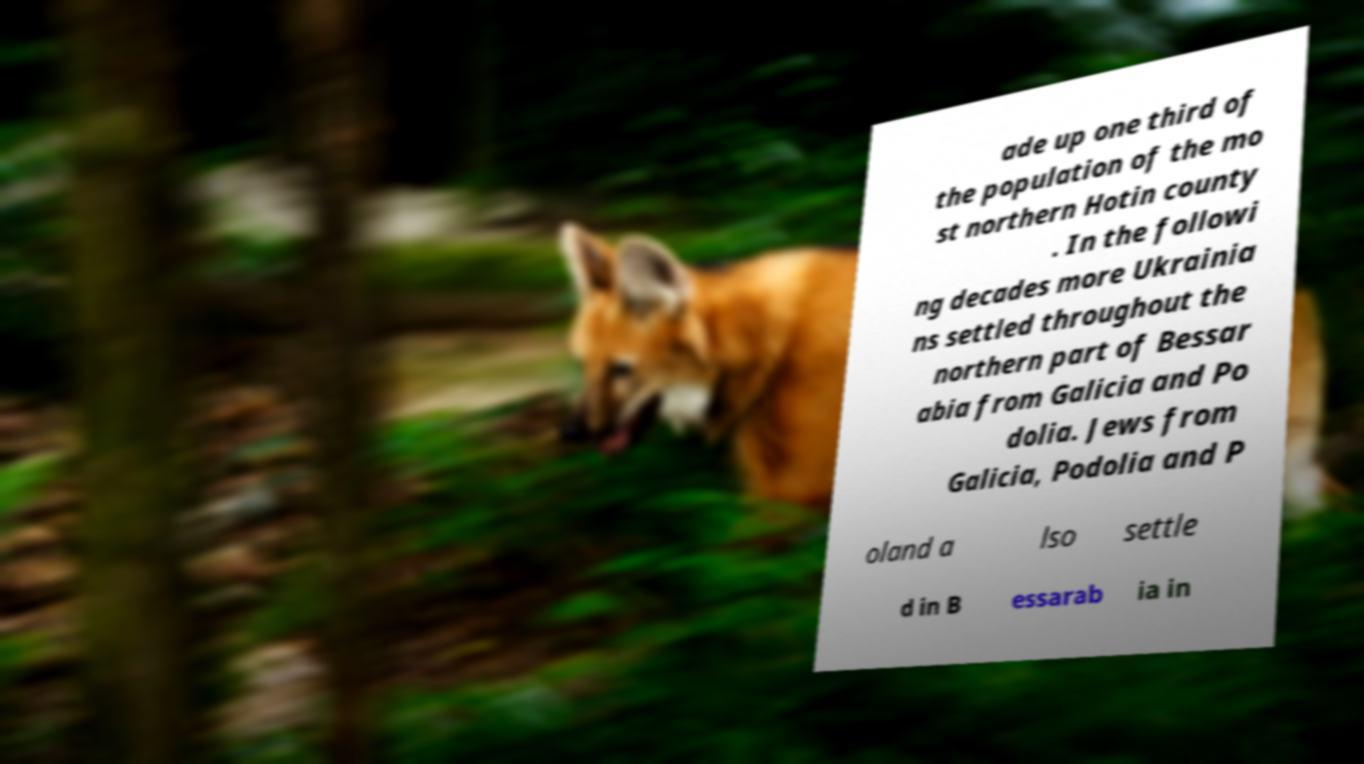Could you extract and type out the text from this image? ade up one third of the population of the mo st northern Hotin county . In the followi ng decades more Ukrainia ns settled throughout the northern part of Bessar abia from Galicia and Po dolia. Jews from Galicia, Podolia and P oland a lso settle d in B essarab ia in 